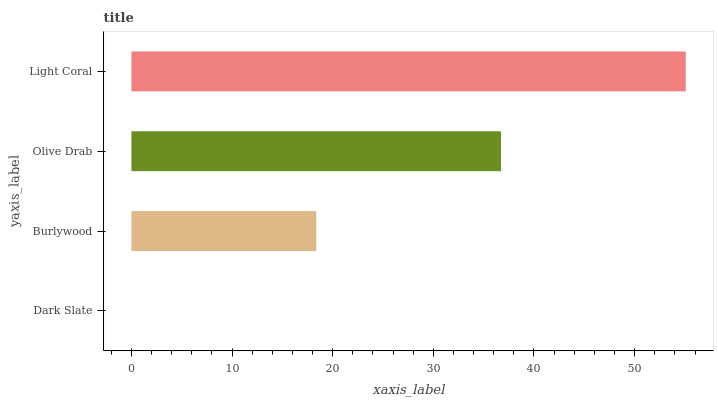Is Dark Slate the minimum?
Answer yes or no. Yes. Is Light Coral the maximum?
Answer yes or no. Yes. Is Burlywood the minimum?
Answer yes or no. No. Is Burlywood the maximum?
Answer yes or no. No. Is Burlywood greater than Dark Slate?
Answer yes or no. Yes. Is Dark Slate less than Burlywood?
Answer yes or no. Yes. Is Dark Slate greater than Burlywood?
Answer yes or no. No. Is Burlywood less than Dark Slate?
Answer yes or no. No. Is Olive Drab the high median?
Answer yes or no. Yes. Is Burlywood the low median?
Answer yes or no. Yes. Is Light Coral the high median?
Answer yes or no. No. Is Olive Drab the low median?
Answer yes or no. No. 